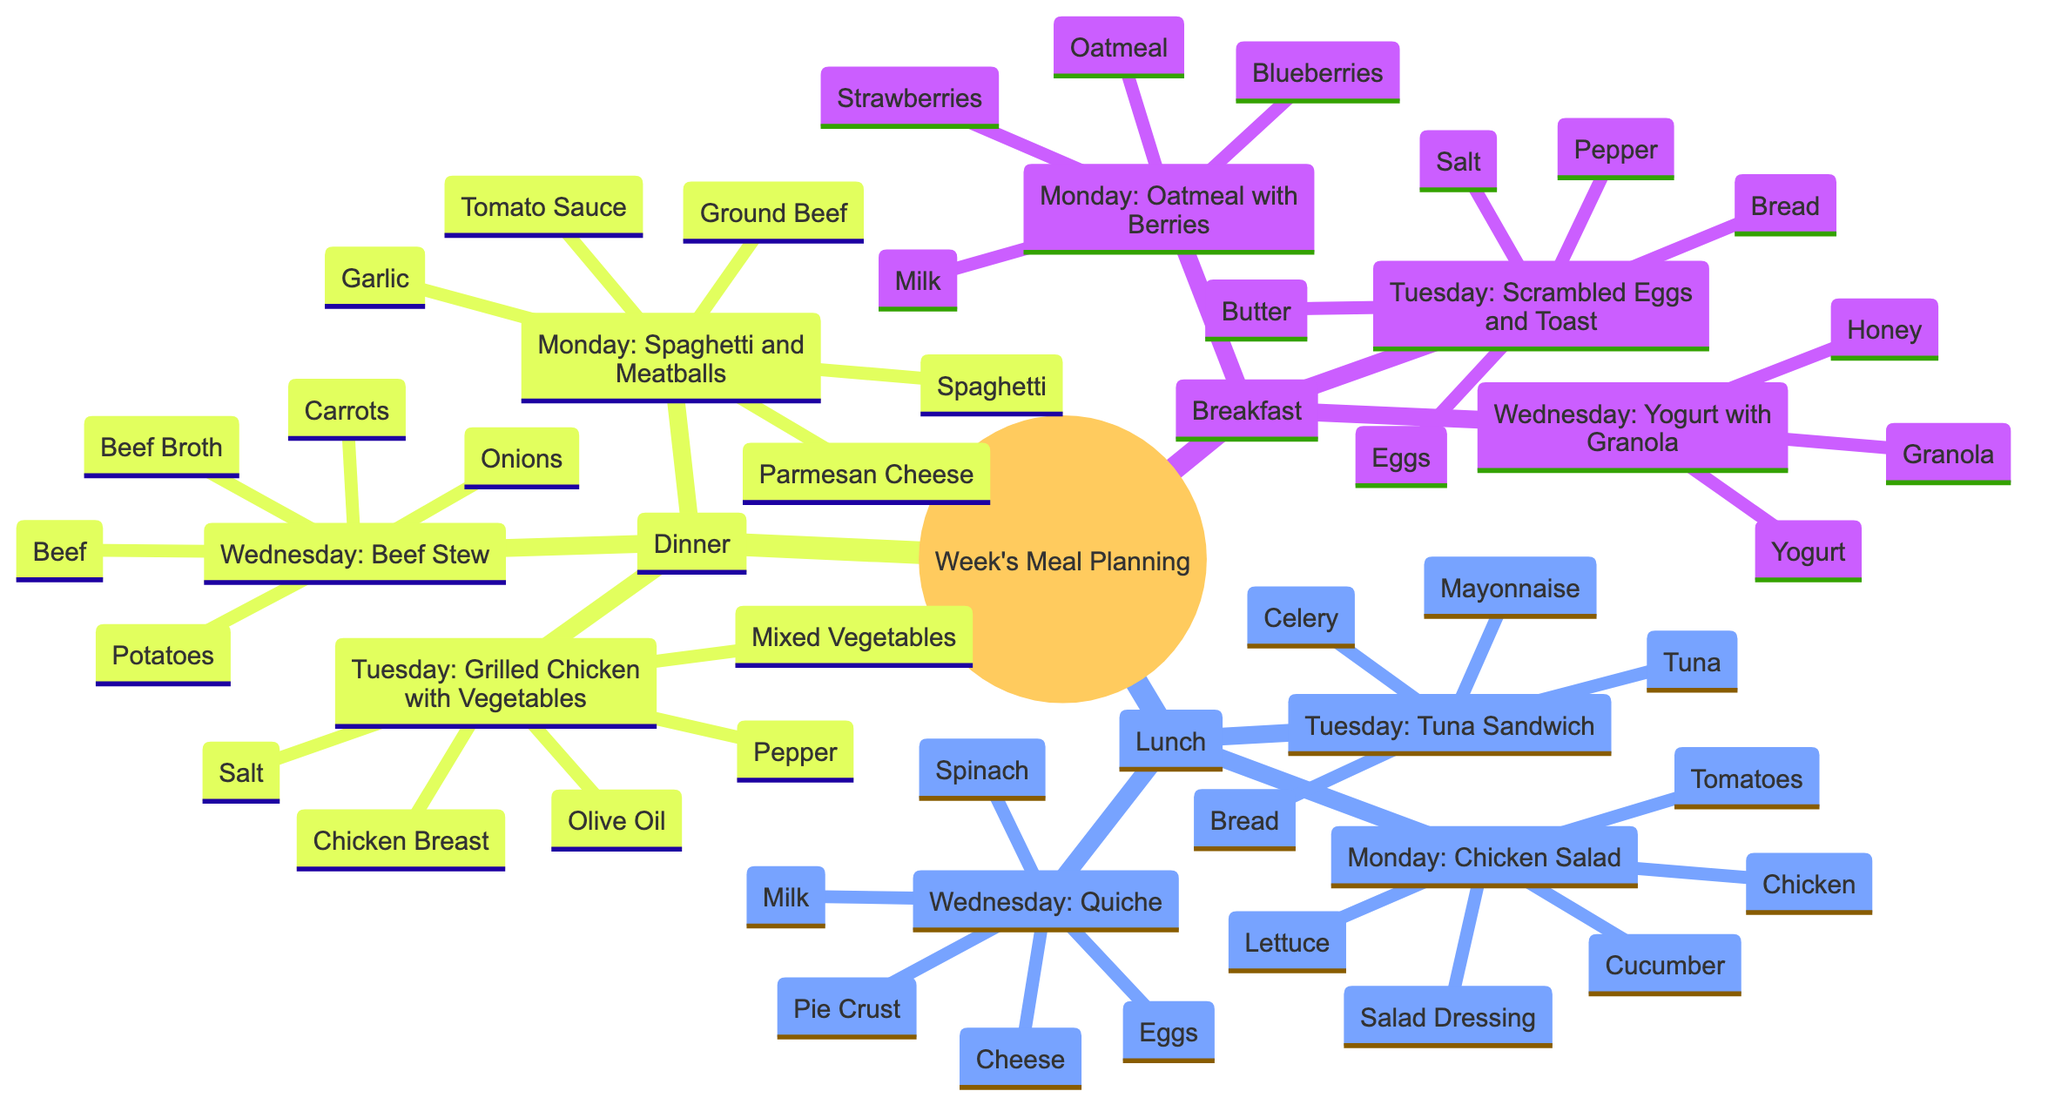What is served for breakfast on Thursday? The diagram shows that Thursday's breakfast is a Smoothie. By looking under the Breakfast node and finding Thursday's meal, we see it listed as a Smoothie.
Answer: Smoothie How many meals are planned for lunch throughout the week? The diagram has a Lunch node, which lists 7 specific meals for each day of the week (Monday through Sunday). Counting these meals, we find that there are 7 of them.
Answer: 7 Which ingredient is used for both Tuesday's lunch and Wednesday's breakfast? We look at the ingredients listed for the Tuesday Tuna Sandwich (which includes Bread) and the Wednesday Yogurt with Granola. Since the only common ingredient between these two meals is the Bread, we determine that it is the shared ingredient.
Answer: Bread What type of meal is served on Saturday? Referring to the meals in the Breakfast, Lunch, and Dinner nodes, we find that Saturday includes French Toast for breakfast, a BLT Sandwich for lunch, and Roast Beef with Potatoes for dinner. The question specifically asks for the type of meal, which could be any of the three types (Breakfast, Lunch, or Dinner). However, all three meals on Saturday fit this description.
Answer: Breakfast, Lunch, Dinner How many ingredients are needed for the Beef Stew dinner? Under the Dinner node, the Beef Stew lists the following ingredients: Beef, Carrots, Potatoes, Onions, and Beef Broth. Counting these ingredients gives us a total of 5 needed for this meal.
Answer: 5 